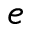<formula> <loc_0><loc_0><loc_500><loc_500>e</formula> 